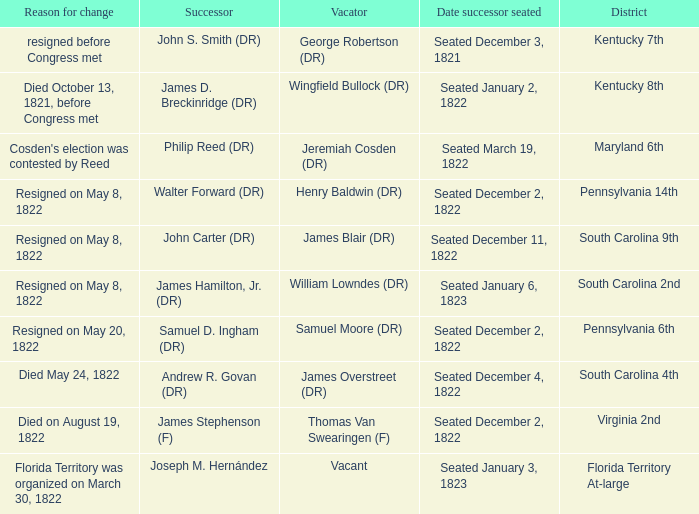What is the reason for change when maryland 6th is the district?  Cosden's election was contested by Reed. 